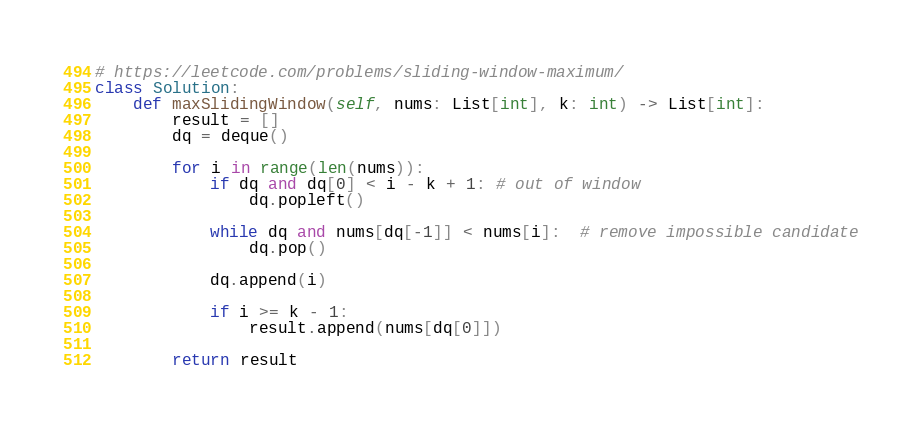<code> <loc_0><loc_0><loc_500><loc_500><_Python_># https://leetcode.com/problems/sliding-window-maximum/
class Solution:
    def maxSlidingWindow(self, nums: List[int], k: int) -> List[int]:
        result = []
        dq = deque()
        
        for i in range(len(nums)):
            if dq and dq[0] < i - k + 1: # out of window
                dq.popleft()
                
            while dq and nums[dq[-1]] < nums[i]:  # remove impossible candidate
                dq.pop()
                
            dq.append(i)
                
            if i >= k - 1:
                result.append(nums[dq[0]])
            
        return result
</code> 